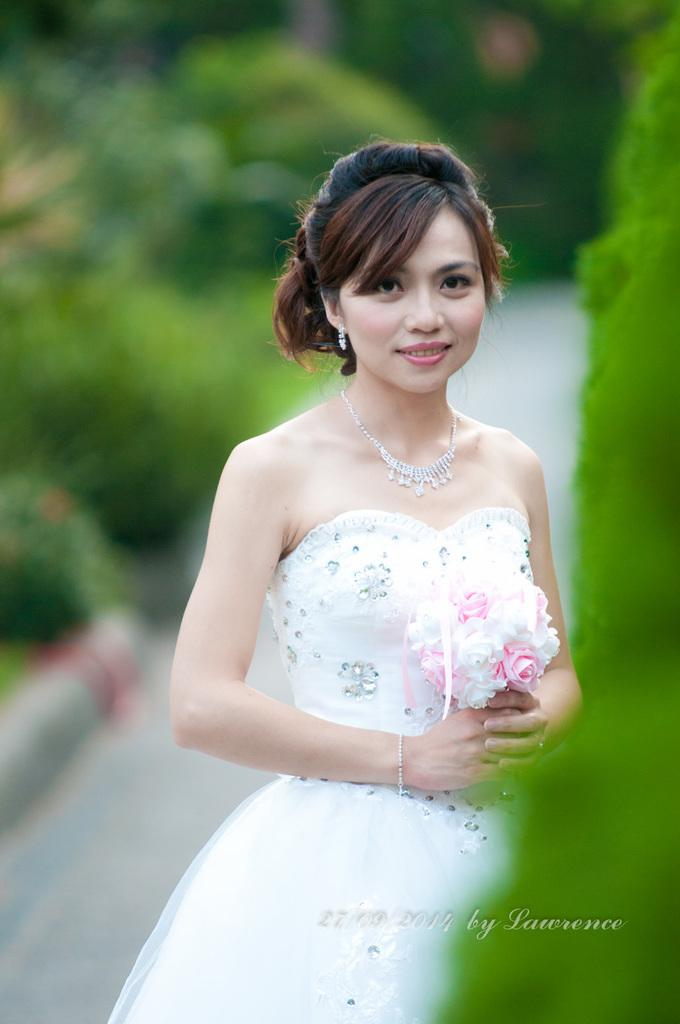Who is the main subject in the image? There is a woman in the image. What is the woman doing in the image? The woman is standing in the image. What is the woman holding in her hand? The woman is holding a bouquet in her hand. What color is the dress the woman is wearing? The woman is wearing a white color dress. What type of branch is the woman using to manage the channel in the image? There is no branch or channel present in the image, and the woman is not managing anything. 